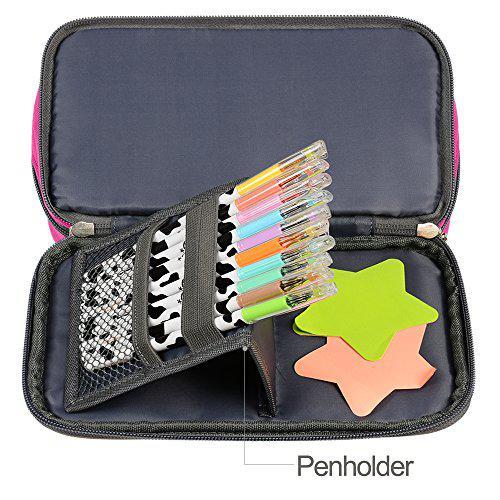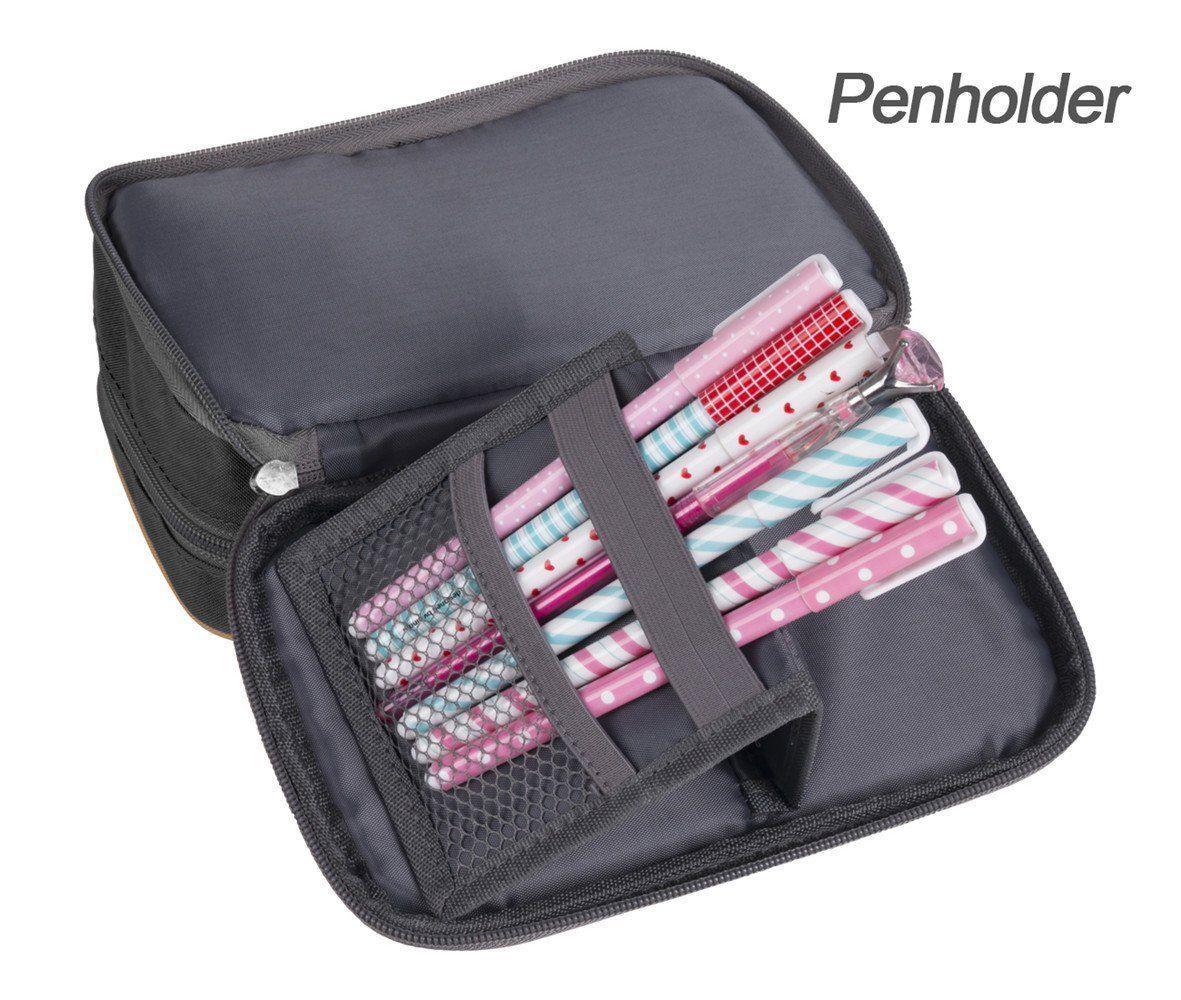The first image is the image on the left, the second image is the image on the right. Given the left and right images, does the statement "Both cases are open to reveal their contents." hold true? Answer yes or no. Yes. The first image is the image on the left, the second image is the image on the right. For the images displayed, is the sentence "Each image shows an open pencil case containing a row of writing implements in a pouch." factually correct? Answer yes or no. Yes. 